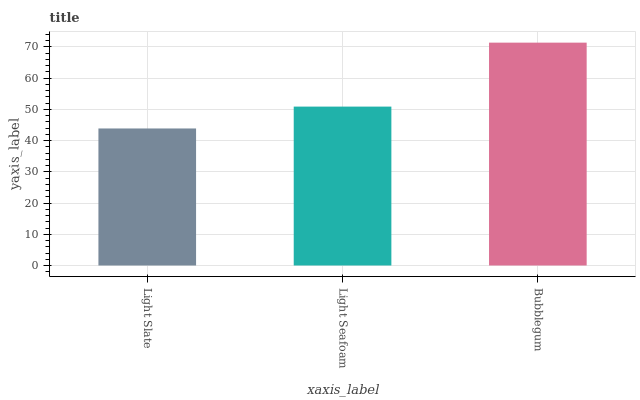Is Light Slate the minimum?
Answer yes or no. Yes. Is Bubblegum the maximum?
Answer yes or no. Yes. Is Light Seafoam the minimum?
Answer yes or no. No. Is Light Seafoam the maximum?
Answer yes or no. No. Is Light Seafoam greater than Light Slate?
Answer yes or no. Yes. Is Light Slate less than Light Seafoam?
Answer yes or no. Yes. Is Light Slate greater than Light Seafoam?
Answer yes or no. No. Is Light Seafoam less than Light Slate?
Answer yes or no. No. Is Light Seafoam the high median?
Answer yes or no. Yes. Is Light Seafoam the low median?
Answer yes or no. Yes. Is Bubblegum the high median?
Answer yes or no. No. Is Bubblegum the low median?
Answer yes or no. No. 